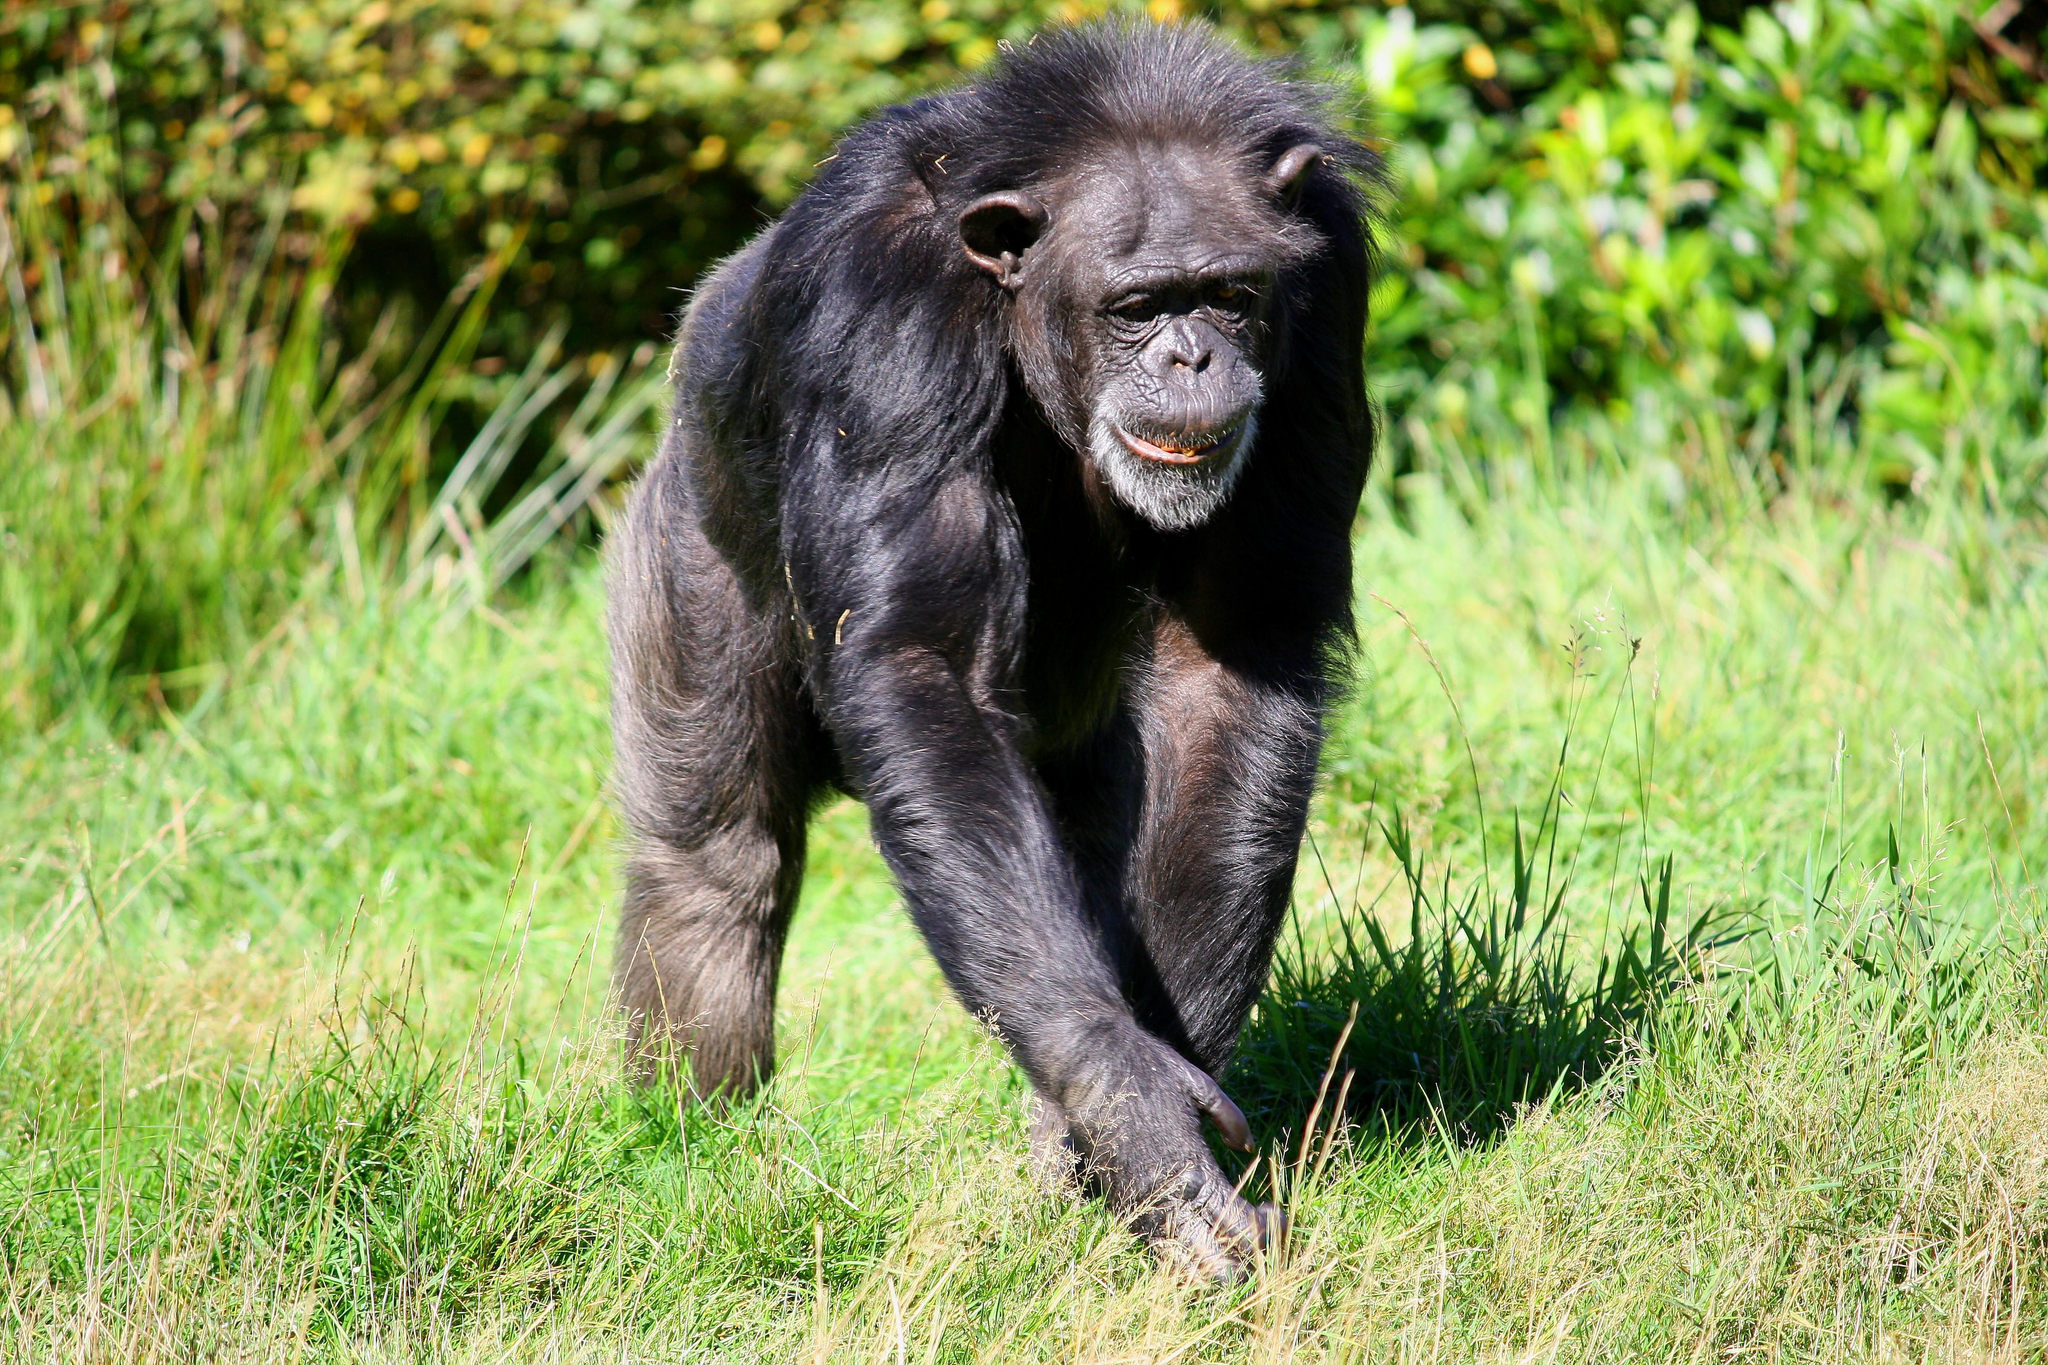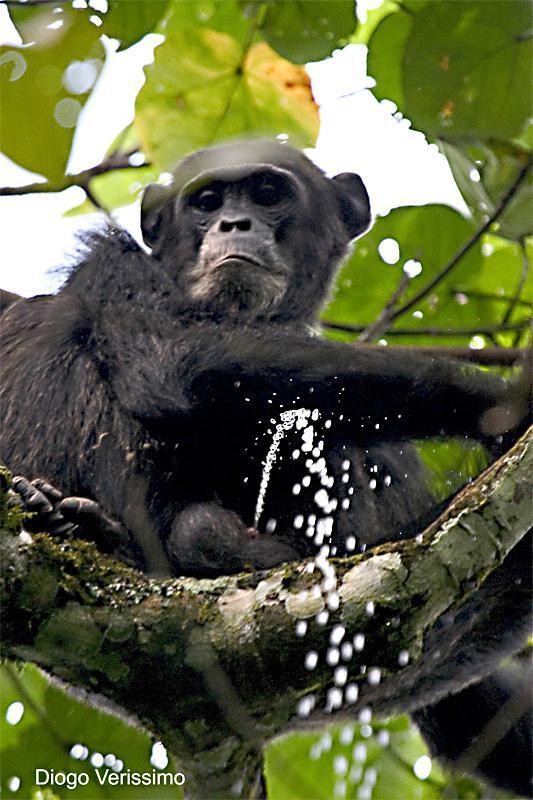The first image is the image on the left, the second image is the image on the right. Evaluate the accuracy of this statement regarding the images: "The primate in the image on the right is sitting on a tree branch.". Is it true? Answer yes or no. Yes. The first image is the image on the left, the second image is the image on the right. Considering the images on both sides, is "The right image shows a chimp looking down over a curved branch from a treetop vantage point." valid? Answer yes or no. Yes. 